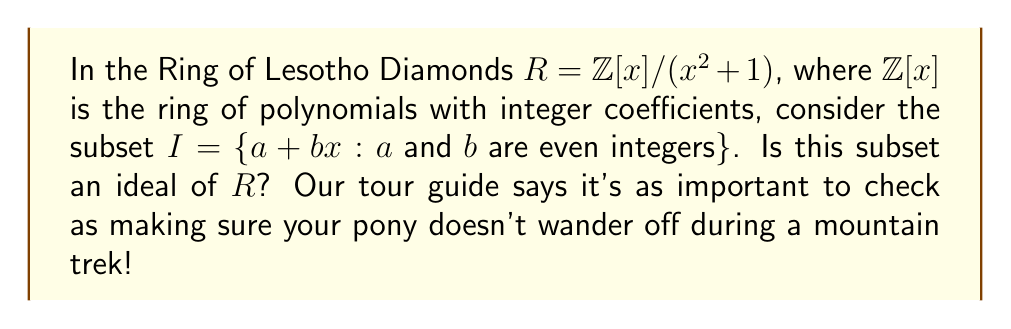Can you solve this math problem? To determine if $I$ is an ideal of $R$, we need to check three conditions:

1. $I$ is non-empty: This is true as $0 + 0x \in I$.

2. $I$ is closed under addition: 
Let $a_1 + b_1x$ and $a_2 + b_2x$ be in $I$. Then:
$$(a_1 + b_1x) + (a_2 + b_2x) = (a_1 + a_2) + (b_1 + b_2)x$$
Since $a_1, a_2, b_1, b_2$ are all even, their sums are also even. So this sum is in $I$.

3. $I$ is closed under multiplication by any element of $R$:
Let $a + bx \in I$ and $r + sx \in R$. Their product is:
$$(a + bx)(r + sx) = (ar - bs) + (as + br)x$$
In $R$, we have $x^2 \equiv -1 \pmod{x^2 + 1}$, so this simplifies to:
$$(ar - bs) + (as + br)x$$

Now, $a$ and $b$ are even, but $r$ and $s$ can be any integers. The problem arises here:
- If $r$ or $s$ is odd, then $(ar - bs)$ and $(as + br)$ may be odd.

For example, if we take $2 + 2x \in I$ and $1 + x \in R$:
$$(2 + 2x)(1 + x) = 2 + 2x + 2x + 2x^2 \equiv 0 + 4x \pmod{x^2 + 1}$$

This result, $4x$, is not in $I$ because its constant term is not even.

Therefore, $I$ is not closed under multiplication by elements of $R$.
Answer: No, $I$ is not an ideal of $R$ because it fails the third condition for ideals: it is not closed under multiplication by all elements of $R$. 